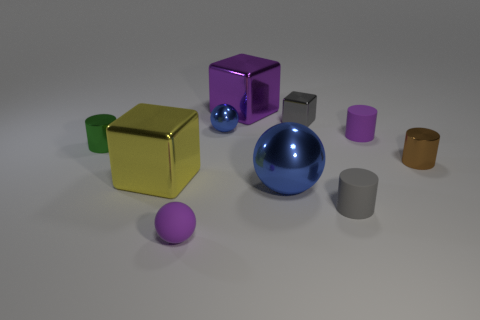Are there fewer tiny green shiny objects behind the green metallic cylinder than blue balls?
Provide a succinct answer. Yes. What is the shape of the tiny brown metallic object?
Keep it short and to the point. Cylinder. What size is the matte object left of the purple cube?
Offer a terse response. Small. The metallic cube that is the same size as the brown thing is what color?
Keep it short and to the point. Gray. Are there any small matte things that have the same color as the small shiny cube?
Your answer should be very brief. Yes. Is the number of metallic cylinders that are to the left of the tiny brown shiny cylinder less than the number of big metal spheres that are left of the small gray metal block?
Your response must be concise. No. There is a thing that is both behind the green metallic object and right of the gray matte object; what material is it made of?
Your response must be concise. Rubber. There is a gray metallic object; is its shape the same as the purple rubber object left of the purple metallic cube?
Give a very brief answer. No. How many other things are the same size as the purple cube?
Your answer should be compact. 2. Are there more small gray cylinders than small blue rubber blocks?
Ensure brevity in your answer.  Yes. 